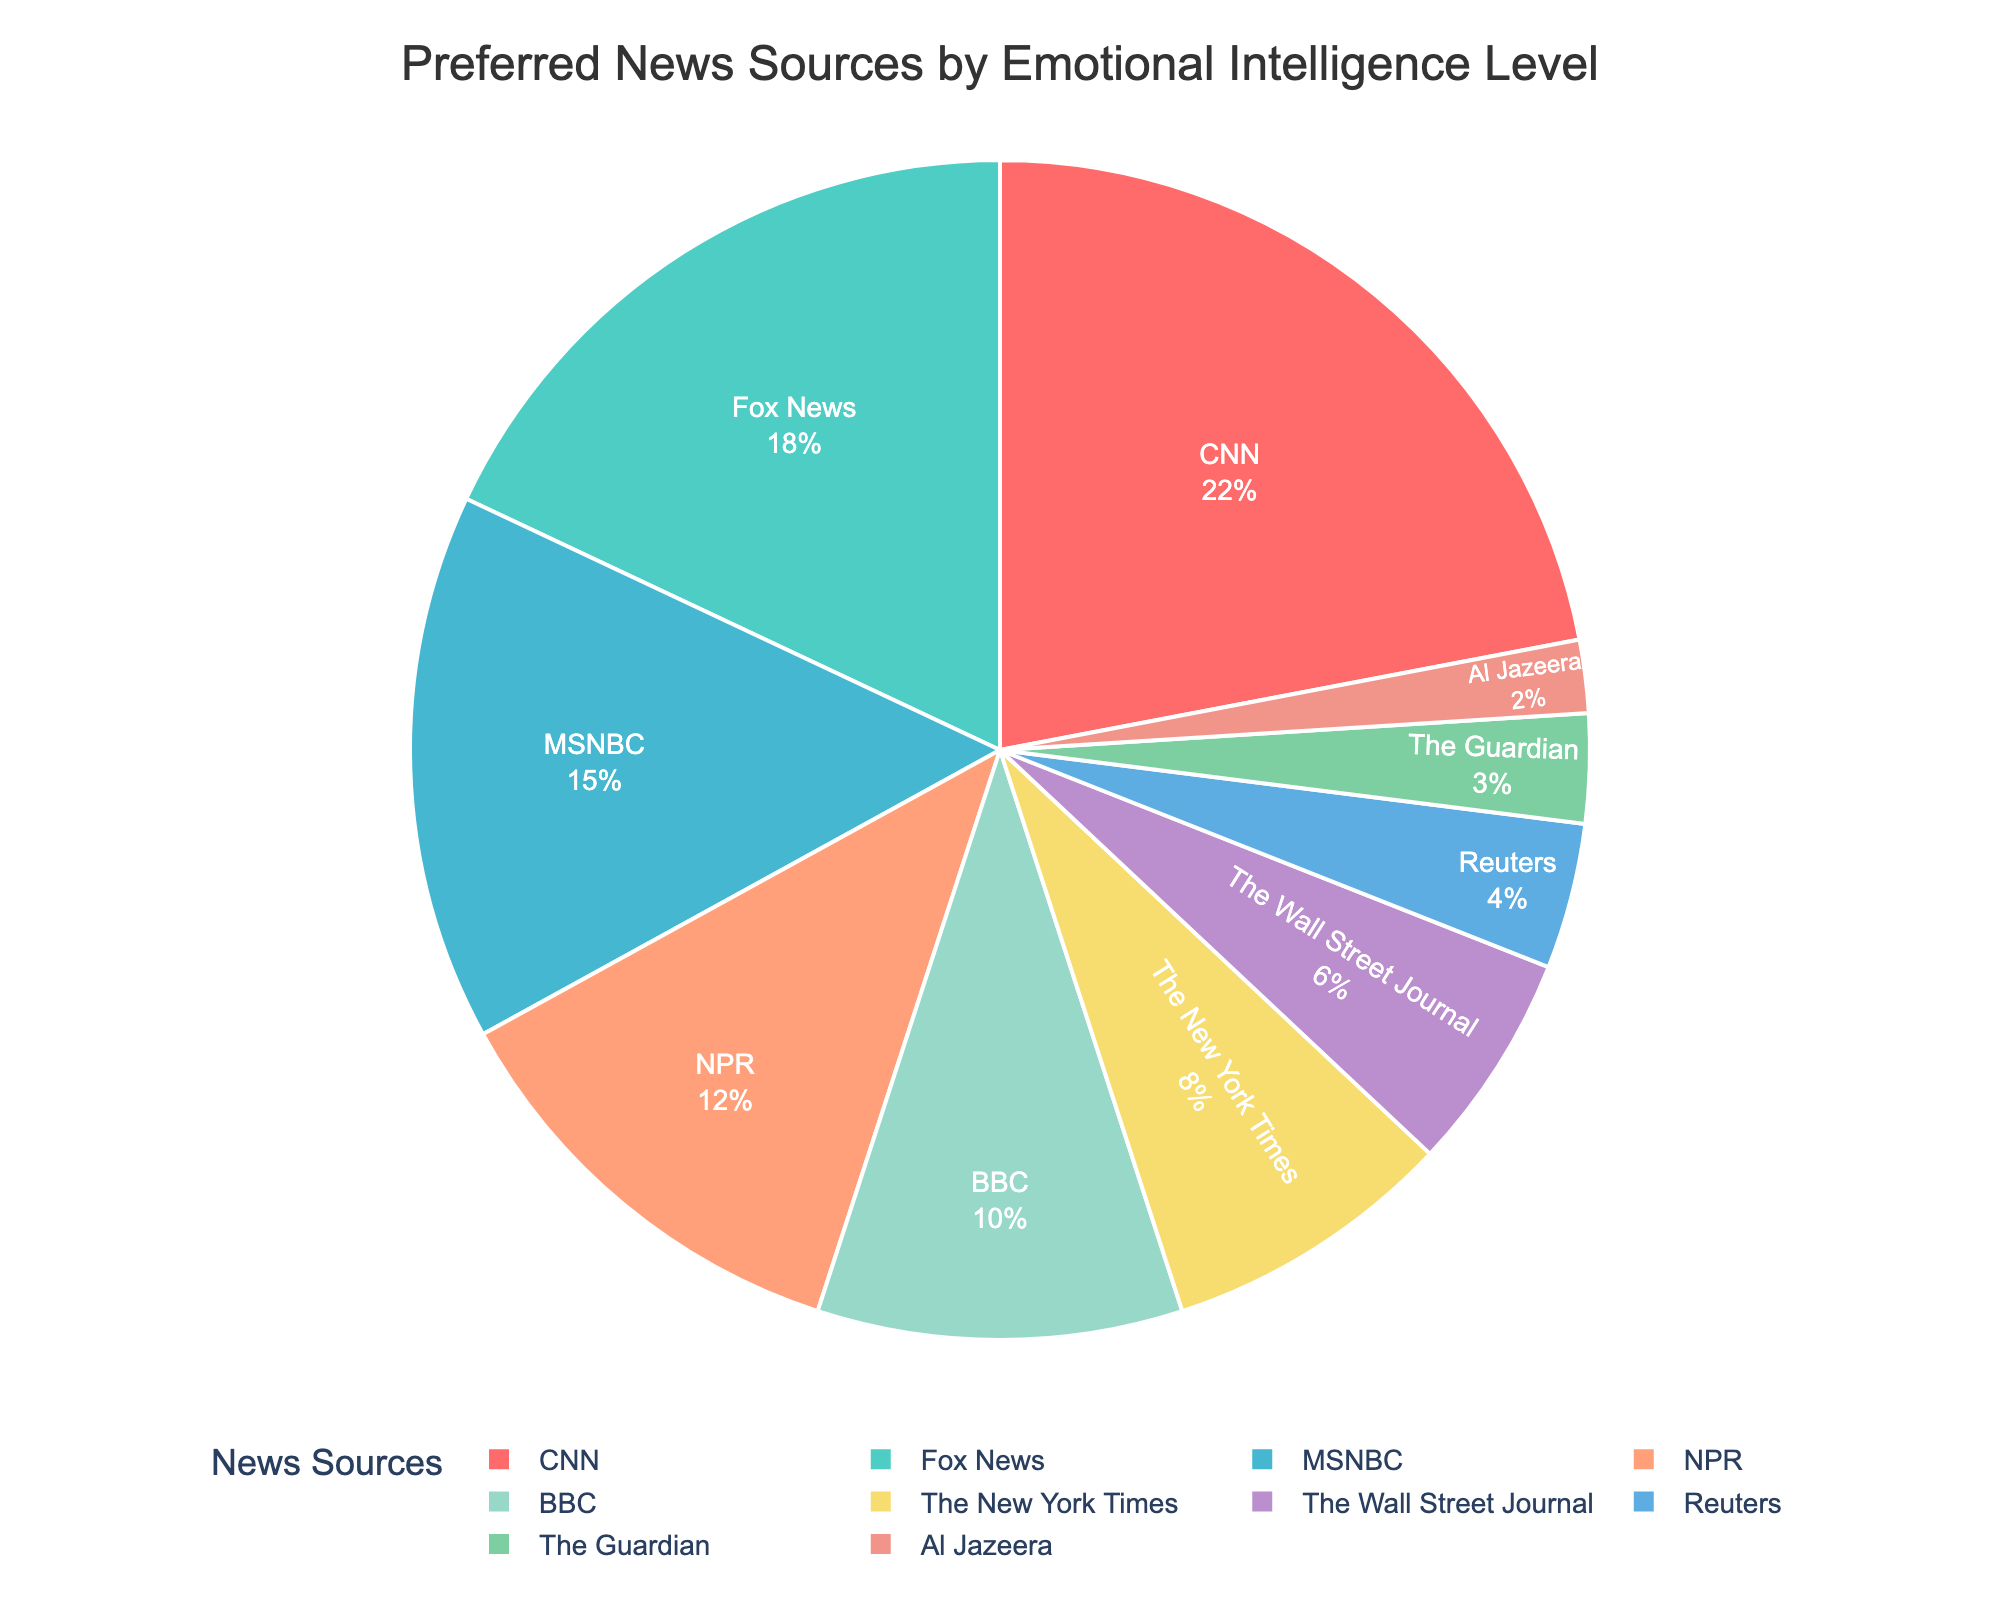Which news source has the highest percentage of preference among people with different levels of emotional intelligence? The figure shows the percentage breakdown of preferred news sources. By identifying the largest slice of the pie chart, we see that CNN has the highest percentage.
Answer: CNN What is the combined percentage of preference for CNN and Fox News? From the figure, CNN accounts for 22% and Fox News accounts for 18%. Summing these values gives us 22 + 18 = 40%.
Answer: 40% How much more preferred is CNN compared to MSNBC? CNN has a preference percentage of 22%, while MSNBC has 15%. The difference is 22 - 15 = 7%.
Answer: 7% Which news sources are preferred by at least 10% of people? The figure shows the percentage breakdown, and the sources with at least 10% preference are CNN (22%), Fox News (18%), MSNBC (15%), NPR (12%), and BBC (10%).
Answer: CNN, Fox News, MSNBC, NPR, BBC What is the least preferred news source according to the figure? The smallest slice of the pie chart corresponds to Al Jazeera with a 2% preference.
Answer: Al Jazeera How do the preferences for BBC and NPR compare in terms of percentage difference? From the figure, BBC has a preference of 10%, and NPR has 12%. The difference is 12 - 10 = 2%.
Answer: 2% What is the total percentage of preference for the bottom three news sources? The bottom three sources are The Guardian (3%), Al Jazeera (2%), and Reuters (4%). Adding these gives 3 + 2 + 4 = 9%.
Answer: 9% If we combine the preferences for The New York Times and The Wall Street Journal, do they sum to more than the preference for NPR? The New York Times has 8% and The Wall Street Journal has 6%, giving a total of 8 + 6 = 14%. NPR has a preference of 12%, so the combined preference is more than NPR's.
Answer: Yes Which news sources have a combined preference equal to or greater than 50%? We observe CNN (22%), Fox News (18%), and MSNBC (15%). Adding these, we have 22 + 18 + 15 = 55%.
Answer: CNN, Fox News, MSNBC What color represents The Guardian in the pie chart? The figure uses a specific color scheme for different news sources. The Guardian is represented by the slice which is colored green.
Answer: Green 